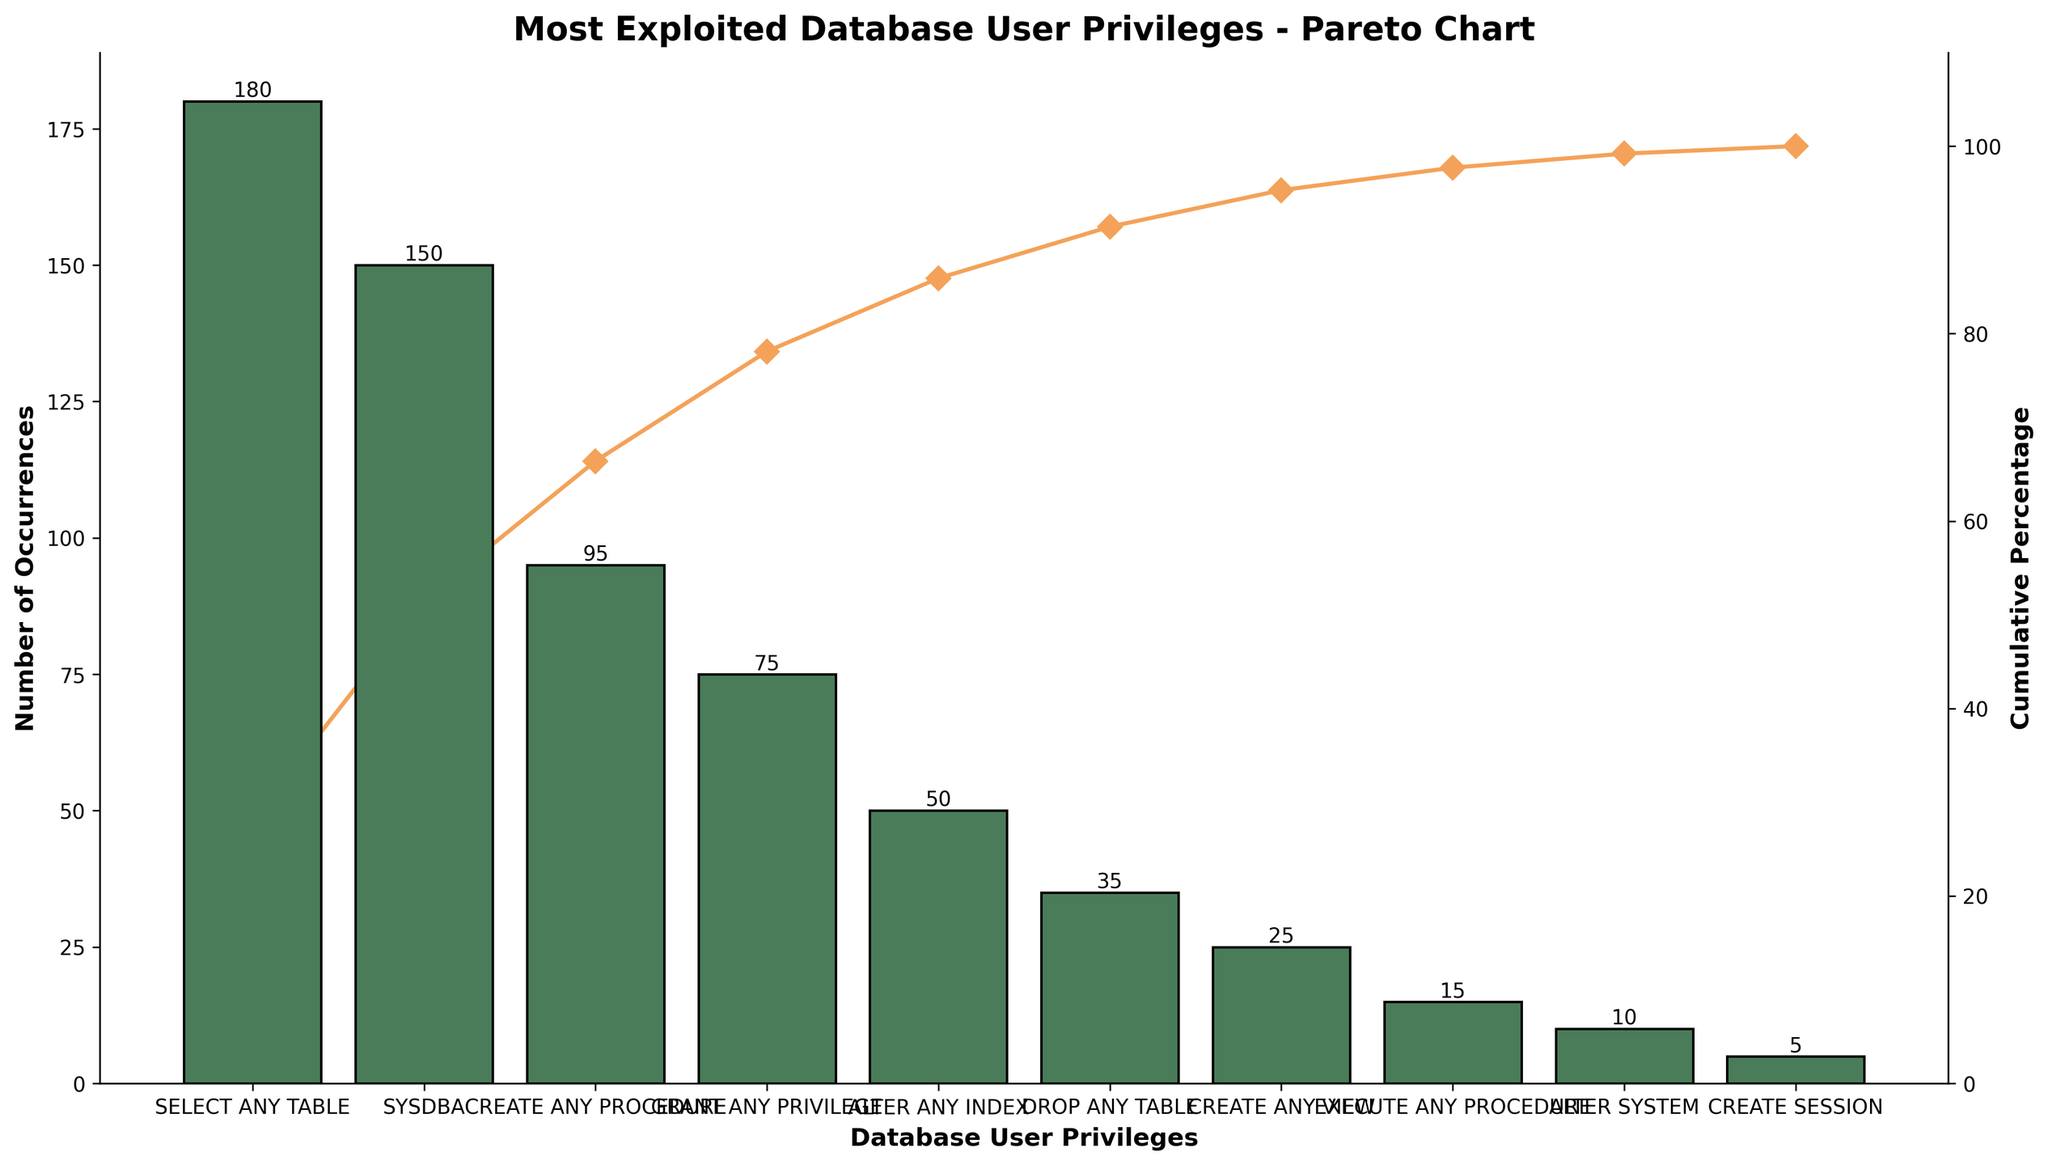Which privilege has the highest number of occurrences? The privilege with the highest bar indicates the most occurrences. From the chart, "SELECT ANY TABLE" has the highest bar height.
Answer: SELECT ANY TABLE What is the cumulative percentage after the third privilege? To find this, look at the cumulative percentage line on the secondary y-axis after the third privilege, "CREATE ANY PROCEDURE". The chart shows it climbs up to 66.4%.
Answer: 66.4% How many occurrences are there for "ALTER SYSTEM"? Check the bar height for "ALTER SYSTEM." The value written on top of the bar is 10.
Answer: 10 Which privilege has the lowest number of occurrences? The smallest bar represents the lowest occurrences. "CREATE SESSION" has the smallest bar height.
Answer: CREATE SESSION What is the difference in occurrences between "SYSDBA" and "EXECUTE ANY PROCEDURE"? Compare the bar heights for "SYSDBA" (150) and "EXECUTE ANY PROCEDURE" (15) and compute the difference: 150 - 15.
Answer: 135 Which privileges cumulatively account for roughly 78% of the occurrences? Check the cumulative percentage line and find the privileges needed to reach about 78%. The first four privileges up to "GRANT ANY PRIVILEGE" reach 78.1%.
Answer: SELECT ANY TABLE, SYSDBA, CREATE ANY PROCEDURE, GRANT ANY PRIVILEGE What is the total number of occurrences for the top three privileges? Add the occurrences of the top three privileges: 180 (SELECT ANY TABLE) + 150 (SYSDBA) + 95 (CREATE ANY PROCEDURE). The total is 425.
Answer: 425 By what percentage does "DROP ANY TABLE" increase the cumulative percentage from the previous privilege? Look at "DROP ANY TABLE" cumulative % (91.4) and subtract "ALTER ANY INDEX" cumulative % (85.9): 91.4 - 85.9. The increase is 5.5%.
Answer: 5.5% Is "GRANT ANY PRIVILEGE" more or less common than "ALTER ANY INDEX"? Compare bar heights for "GRANT ANY PRIVILEGE" and "ALTER ANY INDEX". "GRANT ANY PRIVILEGE" (75) is higher than "ALTER ANY INDEX" (50).
Answer: More common 